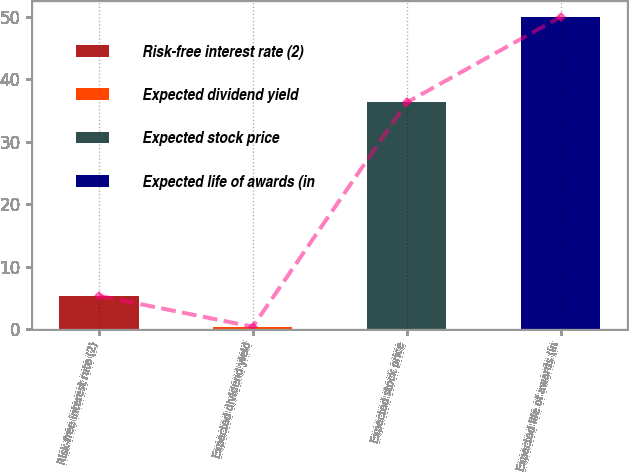Convert chart to OTSL. <chart><loc_0><loc_0><loc_500><loc_500><bar_chart><fcel>Risk-free interest rate (2)<fcel>Expected dividend yield<fcel>Expected stock price<fcel>Expected life of awards (in<nl><fcel>5.36<fcel>0.4<fcel>36.3<fcel>50<nl></chart> 